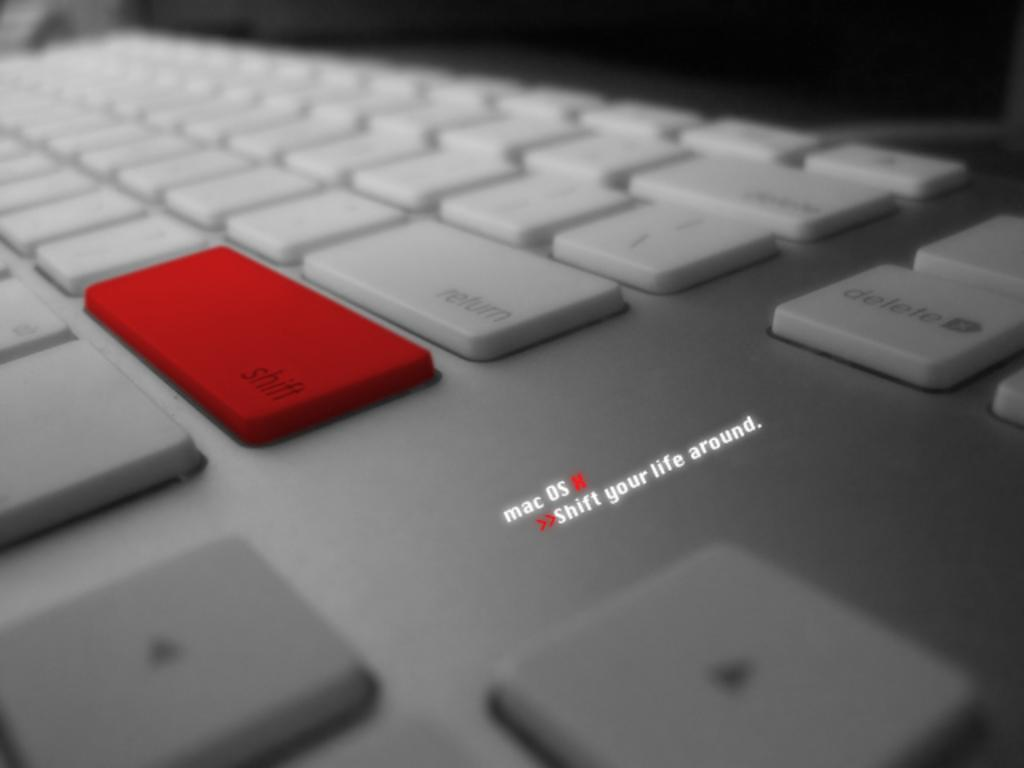<image>
Relay a brief, clear account of the picture shown. An advertisement for Mac with the catchphrase shift your life around 